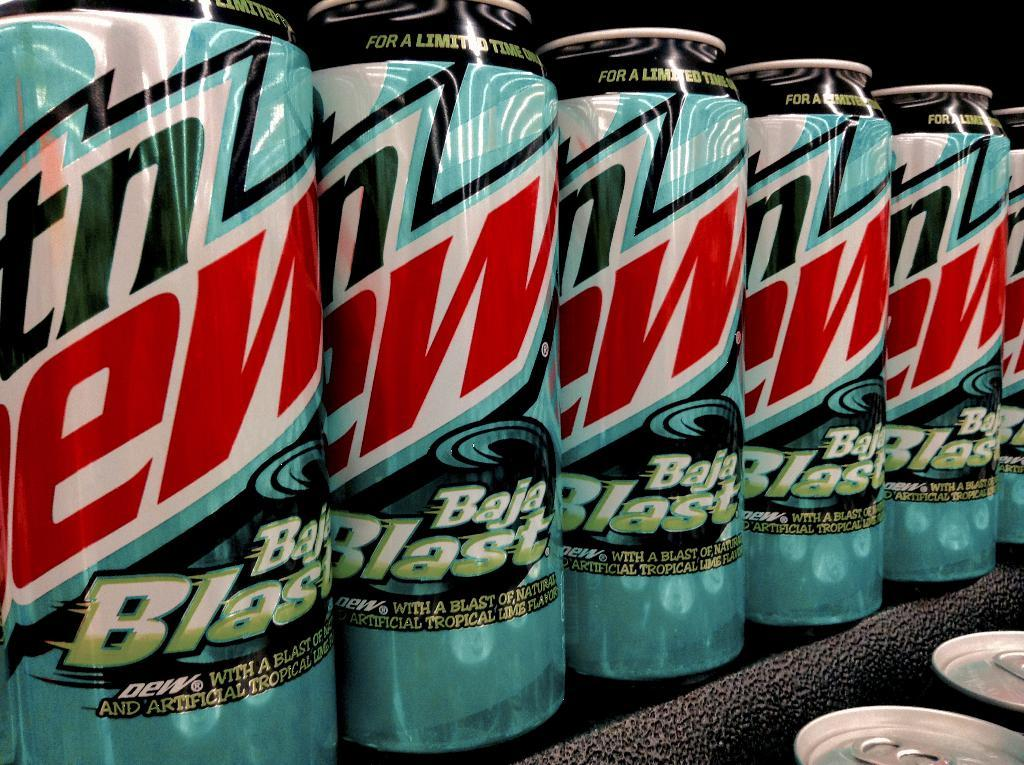Provide a one-sentence caption for the provided image. several cans of mountain dew on a shelf. 